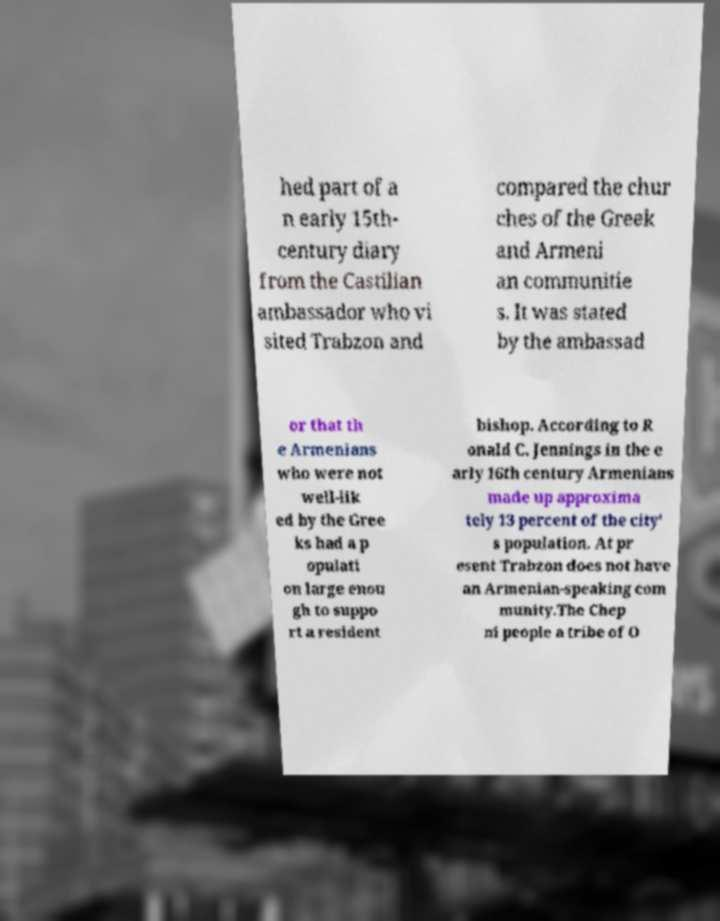Please read and relay the text visible in this image. What does it say? hed part of a n early 15th- century diary from the Castilian ambassador who vi sited Trabzon and compared the chur ches of the Greek and Armeni an communitie s. It was stated by the ambassad or that th e Armenians who were not well-lik ed by the Gree ks had a p opulati on large enou gh to suppo rt a resident bishop. According to R onald C. Jennings in the e arly 16th century Armenians made up approxima tely 13 percent of the city' s population. At pr esent Trabzon does not have an Armenian-speaking com munity.The Chep ni people a tribe of O 